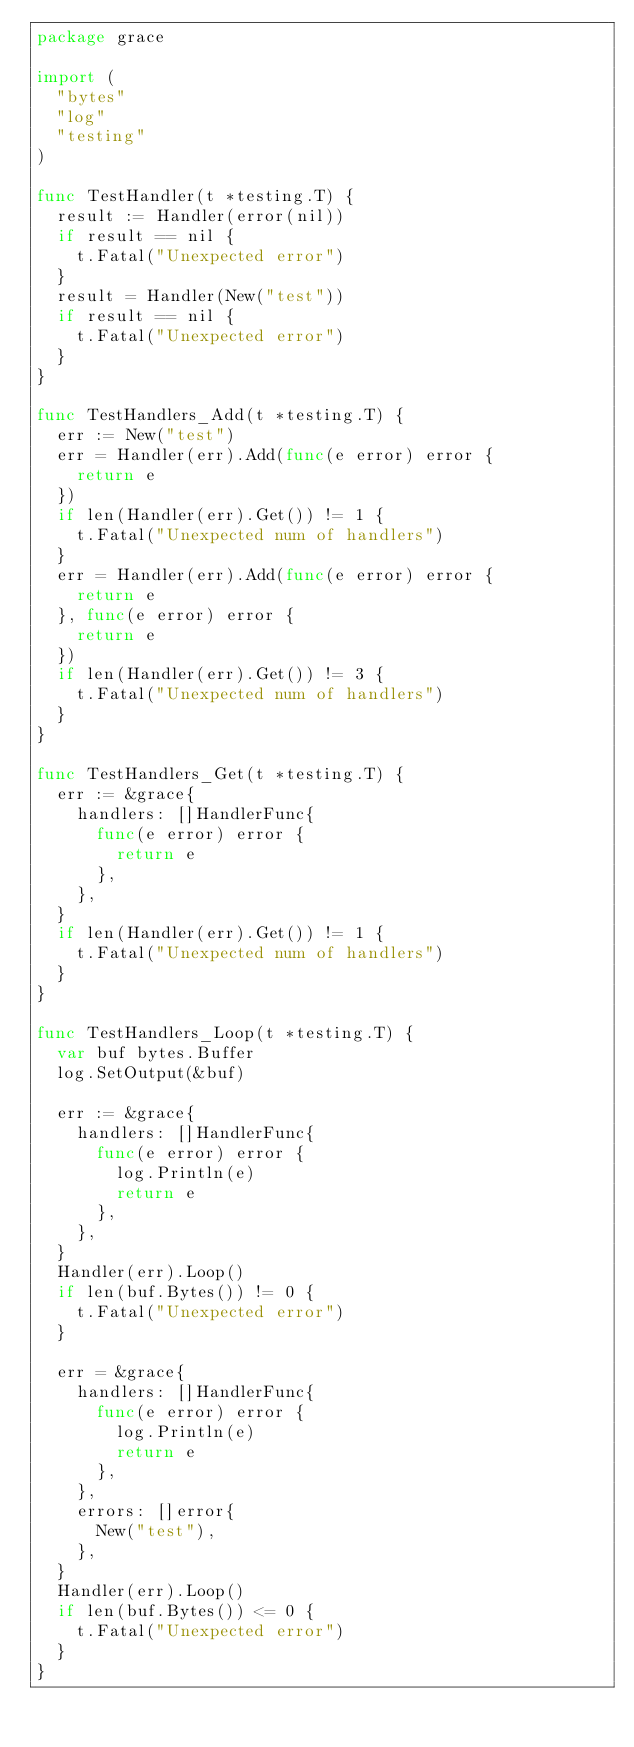<code> <loc_0><loc_0><loc_500><loc_500><_Go_>package grace

import (
	"bytes"
	"log"
	"testing"
)

func TestHandler(t *testing.T) {
	result := Handler(error(nil))
	if result == nil {
		t.Fatal("Unexpected error")
	}
	result = Handler(New("test"))
	if result == nil {
		t.Fatal("Unexpected error")
	}
}

func TestHandlers_Add(t *testing.T) {
	err := New("test")
	err = Handler(err).Add(func(e error) error {
		return e
	})
	if len(Handler(err).Get()) != 1 {
		t.Fatal("Unexpected num of handlers")
	}
	err = Handler(err).Add(func(e error) error {
		return e
	}, func(e error) error {
		return e
	})
	if len(Handler(err).Get()) != 3 {
		t.Fatal("Unexpected num of handlers")
	}
}

func TestHandlers_Get(t *testing.T) {
	err := &grace{
		handlers: []HandlerFunc{
			func(e error) error {
				return e
			},
		},
	}
	if len(Handler(err).Get()) != 1 {
		t.Fatal("Unexpected num of handlers")
	}
}

func TestHandlers_Loop(t *testing.T) {
	var buf bytes.Buffer
	log.SetOutput(&buf)

	err := &grace{
		handlers: []HandlerFunc{
			func(e error) error {
				log.Println(e)
				return e
			},
		},
	}
	Handler(err).Loop()
	if len(buf.Bytes()) != 0 {
		t.Fatal("Unexpected error")
	}

	err = &grace{
		handlers: []HandlerFunc{
			func(e error) error {
				log.Println(e)
				return e
			},
		},
		errors: []error{
			New("test"),
		},
	}
	Handler(err).Loop()
	if len(buf.Bytes()) <= 0 {
		t.Fatal("Unexpected error")
	}
}
</code> 